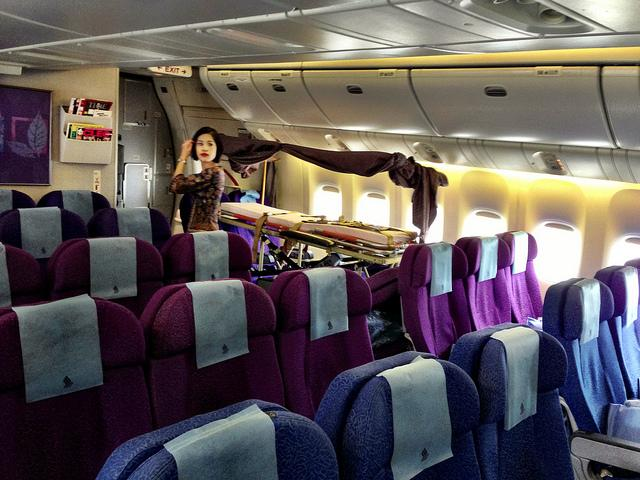Which country does this airline likely belong to?

Choices:
A) china
B) japan
C) singapore
D) thailand thailand 